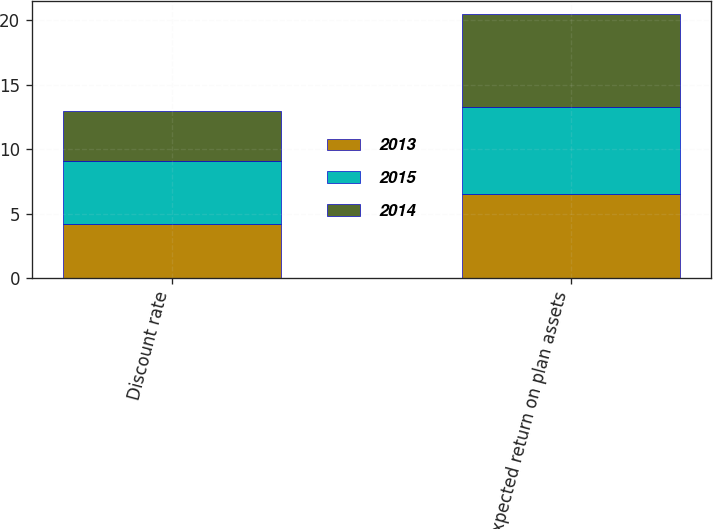<chart> <loc_0><loc_0><loc_500><loc_500><stacked_bar_chart><ecel><fcel>Discount rate<fcel>Expected return on plan assets<nl><fcel>2013<fcel>4.2<fcel>6.5<nl><fcel>2015<fcel>4.85<fcel>6.75<nl><fcel>2014<fcel>3.95<fcel>7.25<nl></chart> 